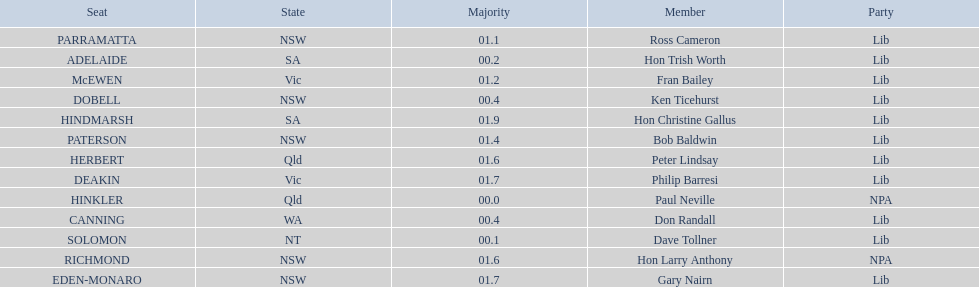What party had the most seats? Lib. 